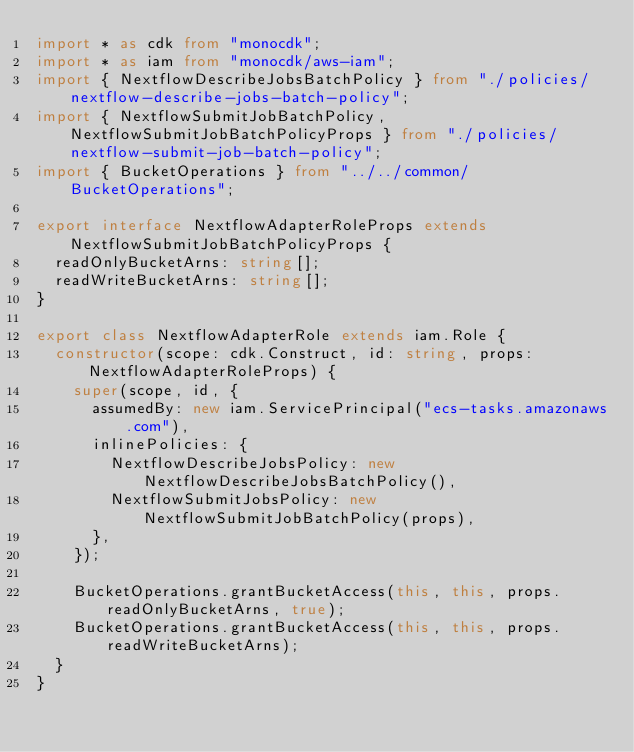<code> <loc_0><loc_0><loc_500><loc_500><_TypeScript_>import * as cdk from "monocdk";
import * as iam from "monocdk/aws-iam";
import { NextflowDescribeJobsBatchPolicy } from "./policies/nextflow-describe-jobs-batch-policy";
import { NextflowSubmitJobBatchPolicy, NextflowSubmitJobBatchPolicyProps } from "./policies/nextflow-submit-job-batch-policy";
import { BucketOperations } from "../../common/BucketOperations";

export interface NextflowAdapterRoleProps extends NextflowSubmitJobBatchPolicyProps {
  readOnlyBucketArns: string[];
  readWriteBucketArns: string[];
}

export class NextflowAdapterRole extends iam.Role {
  constructor(scope: cdk.Construct, id: string, props: NextflowAdapterRoleProps) {
    super(scope, id, {
      assumedBy: new iam.ServicePrincipal("ecs-tasks.amazonaws.com"),
      inlinePolicies: {
        NextflowDescribeJobsPolicy: new NextflowDescribeJobsBatchPolicy(),
        NextflowSubmitJobsPolicy: new NextflowSubmitJobBatchPolicy(props),
      },
    });

    BucketOperations.grantBucketAccess(this, this, props.readOnlyBucketArns, true);
    BucketOperations.grantBucketAccess(this, this, props.readWriteBucketArns);
  }
}
</code> 